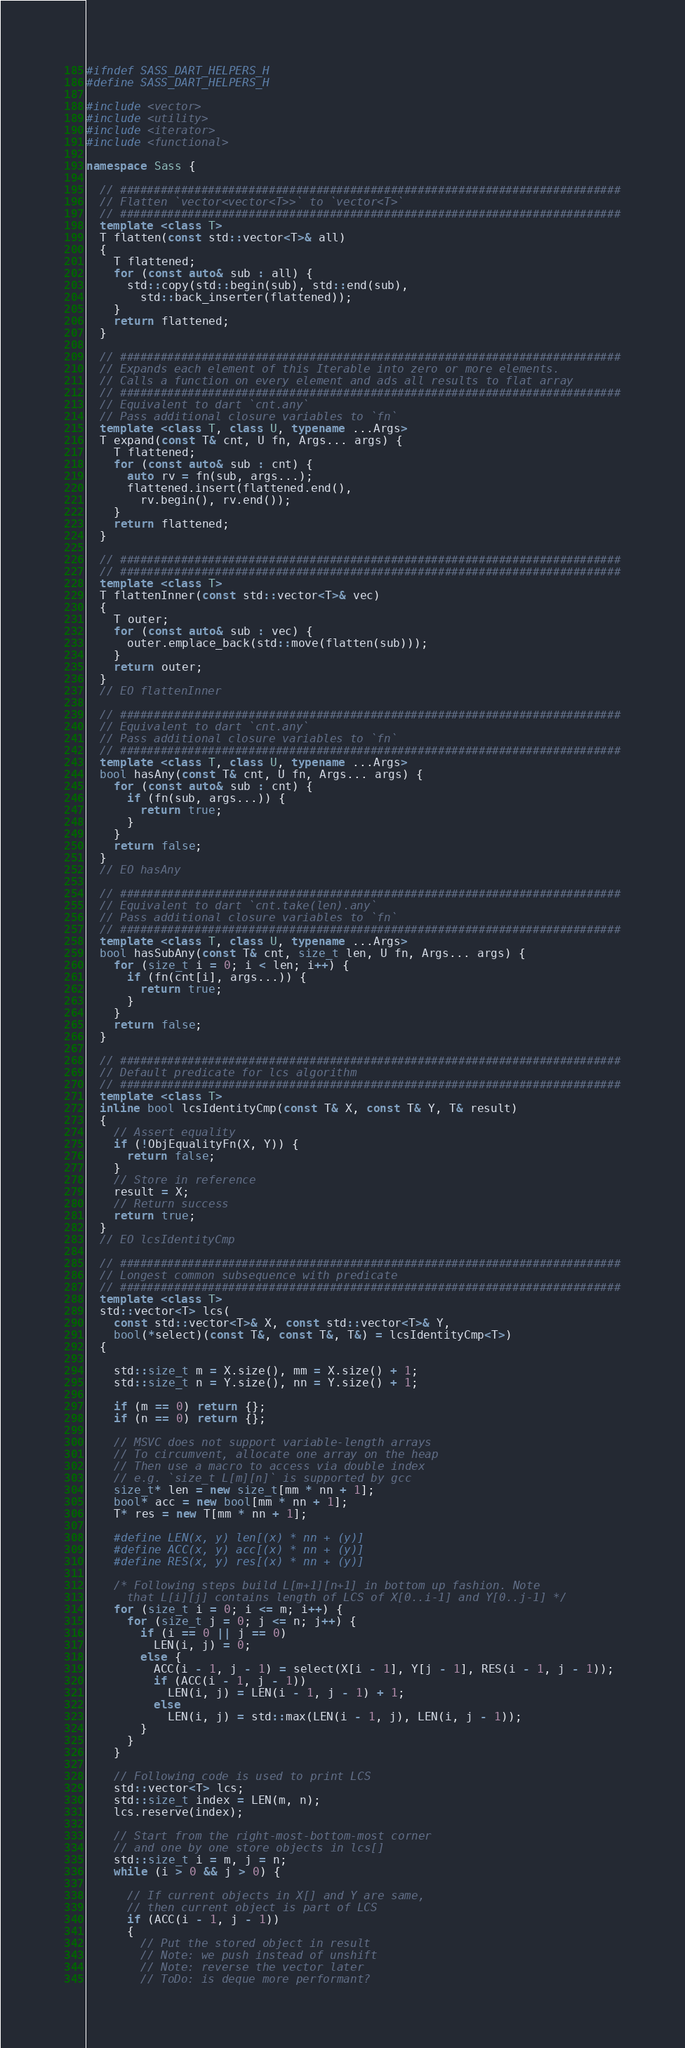<code> <loc_0><loc_0><loc_500><loc_500><_C++_>#ifndef SASS_DART_HELPERS_H
#define SASS_DART_HELPERS_H

#include <vector>
#include <utility>
#include <iterator>
#include <functional>

namespace Sass {

  // ##########################################################################
  // Flatten `vector<vector<T>>` to `vector<T>`
  // ##########################################################################
  template <class T>
  T flatten(const std::vector<T>& all)
  {
    T flattened;
    for (const auto& sub : all) {
      std::copy(std::begin(sub), std::end(sub),
        std::back_inserter(flattened));
    }
    return flattened;
  }

  // ##########################################################################
  // Expands each element of this Iterable into zero or more elements.
  // Calls a function on every element and ads all results to flat array
  // ##########################################################################
  // Equivalent to dart `cnt.any`
  // Pass additional closure variables to `fn`
  template <class T, class U, typename ...Args>
  T expand(const T& cnt, U fn, Args... args) {
    T flattened;
    for (const auto& sub : cnt) {
      auto rv = fn(sub, args...);
      flattened.insert(flattened.end(),
        rv.begin(), rv.end());
    }
    return flattened;
  }

  // ##########################################################################
  // ##########################################################################
  template <class T>
  T flattenInner(const std::vector<T>& vec)
  {
    T outer;
    for (const auto& sub : vec) {
      outer.emplace_back(std::move(flatten(sub)));
    }
    return outer;
  }
  // EO flattenInner

  // ##########################################################################
  // Equivalent to dart `cnt.any`
  // Pass additional closure variables to `fn`
  // ##########################################################################
  template <class T, class U, typename ...Args>
  bool hasAny(const T& cnt, U fn, Args... args) {
    for (const auto& sub : cnt) {
      if (fn(sub, args...)) {
        return true;
      }
    }
    return false;
  }
  // EO hasAny

  // ##########################################################################
  // Equivalent to dart `cnt.take(len).any`
  // Pass additional closure variables to `fn`
  // ##########################################################################
  template <class T, class U, typename ...Args>
  bool hasSubAny(const T& cnt, size_t len, U fn, Args... args) {
    for (size_t i = 0; i < len; i++) {
      if (fn(cnt[i], args...)) {
        return true;
      }
    }
    return false;
  }

  // ##########################################################################
  // Default predicate for lcs algorithm
  // ##########################################################################
  template <class T>
  inline bool lcsIdentityCmp(const T& X, const T& Y, T& result)
  {
    // Assert equality
    if (!ObjEqualityFn(X, Y)) {
      return false;
    }
    // Store in reference
    result = X;
    // Return success
    return true;
  }
  // EO lcsIdentityCmp

  // ##########################################################################
  // Longest common subsequence with predicate
  // ##########################################################################
  template <class T>
  std::vector<T> lcs(
    const std::vector<T>& X, const std::vector<T>& Y,
    bool(*select)(const T&, const T&, T&) = lcsIdentityCmp<T>)
  {

    std::size_t m = X.size(), mm = X.size() + 1;
    std::size_t n = Y.size(), nn = Y.size() + 1;

    if (m == 0) return {};
    if (n == 0) return {};

    // MSVC does not support variable-length arrays
    // To circumvent, allocate one array on the heap
    // Then use a macro to access via double index
    // e.g. `size_t L[m][n]` is supported by gcc
    size_t* len = new size_t[mm * nn + 1];
    bool* acc = new bool[mm * nn + 1];
    T* res = new T[mm * nn + 1];

    #define LEN(x, y) len[(x) * nn + (y)]
    #define ACC(x, y) acc[(x) * nn + (y)]
    #define RES(x, y) res[(x) * nn + (y)]

    /* Following steps build L[m+1][n+1] in bottom up fashion. Note
      that L[i][j] contains length of LCS of X[0..i-1] and Y[0..j-1] */
    for (size_t i = 0; i <= m; i++) {
      for (size_t j = 0; j <= n; j++) {
        if (i == 0 || j == 0)
          LEN(i, j) = 0;
        else {
          ACC(i - 1, j - 1) = select(X[i - 1], Y[j - 1], RES(i - 1, j - 1));
          if (ACC(i - 1, j - 1))
            LEN(i, j) = LEN(i - 1, j - 1) + 1;
          else
            LEN(i, j) = std::max(LEN(i - 1, j), LEN(i, j - 1));
        }
      }
    }

    // Following code is used to print LCS
    std::vector<T> lcs;
    std::size_t index = LEN(m, n);
    lcs.reserve(index);

    // Start from the right-most-bottom-most corner
    // and one by one store objects in lcs[]
    std::size_t i = m, j = n;
    while (i > 0 && j > 0) {

      // If current objects in X[] and Y are same,
      // then current object is part of LCS
      if (ACC(i - 1, j - 1))
      {
        // Put the stored object in result
        // Note: we push instead of unshift
        // Note: reverse the vector later
        // ToDo: is deque more performant?</code> 